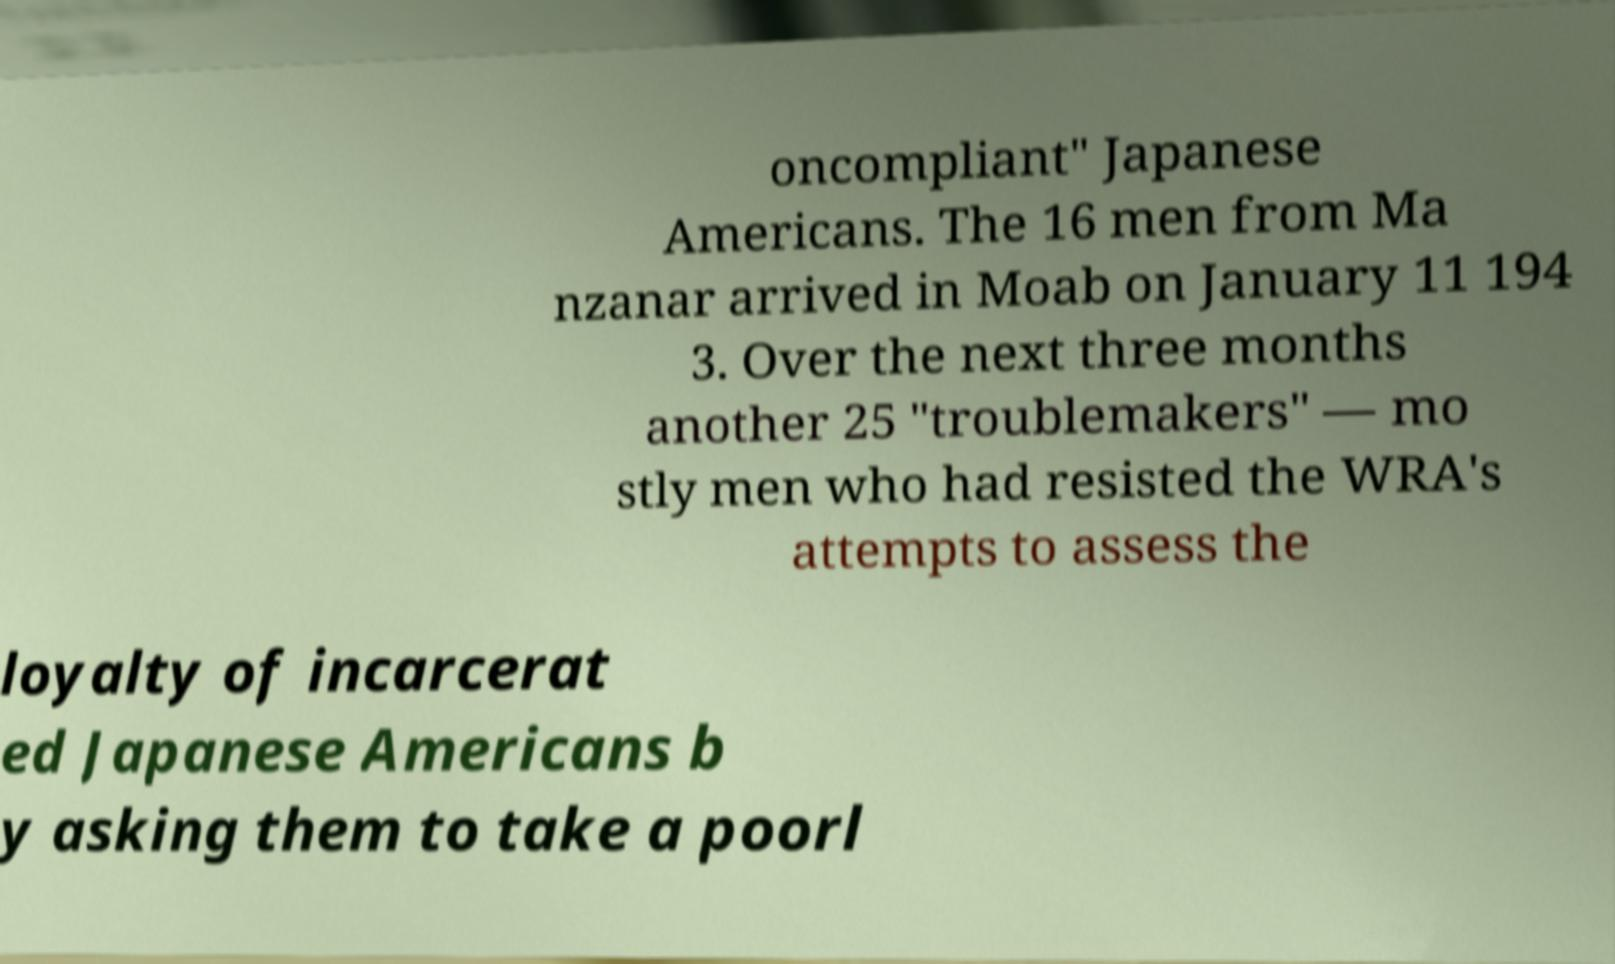Please read and relay the text visible in this image. What does it say? oncompliant" Japanese Americans. The 16 men from Ma nzanar arrived in Moab on January 11 194 3. Over the next three months another 25 "troublemakers" — mo stly men who had resisted the WRA's attempts to assess the loyalty of incarcerat ed Japanese Americans b y asking them to take a poorl 